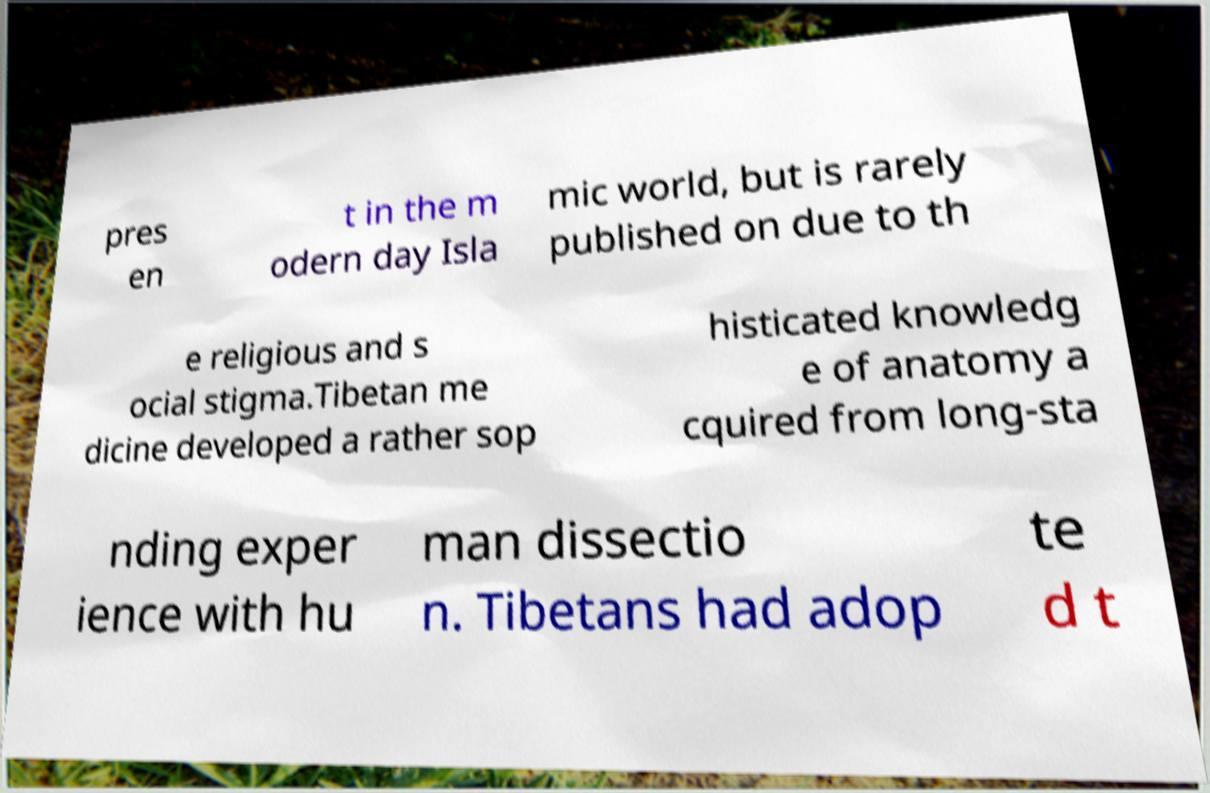I need the written content from this picture converted into text. Can you do that? pres en t in the m odern day Isla mic world, but is rarely published on due to th e religious and s ocial stigma.Tibetan me dicine developed a rather sop histicated knowledg e of anatomy a cquired from long-sta nding exper ience with hu man dissectio n. Tibetans had adop te d t 